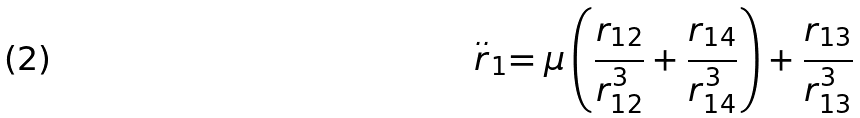Convert formula to latex. <formula><loc_0><loc_0><loc_500><loc_500>\stackrel { . . } { r } _ { 1 } = \mu \left ( \frac { r _ { 1 2 } } { r _ { 1 2 } ^ { 3 } } + \frac { r _ { 1 4 } } { r _ { 1 4 } ^ { 3 } } \right ) + \frac { r _ { 1 3 } } { r _ { 1 3 } ^ { 3 } }</formula> 